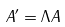<formula> <loc_0><loc_0><loc_500><loc_500>A ^ { \prime } = \Lambda A</formula> 